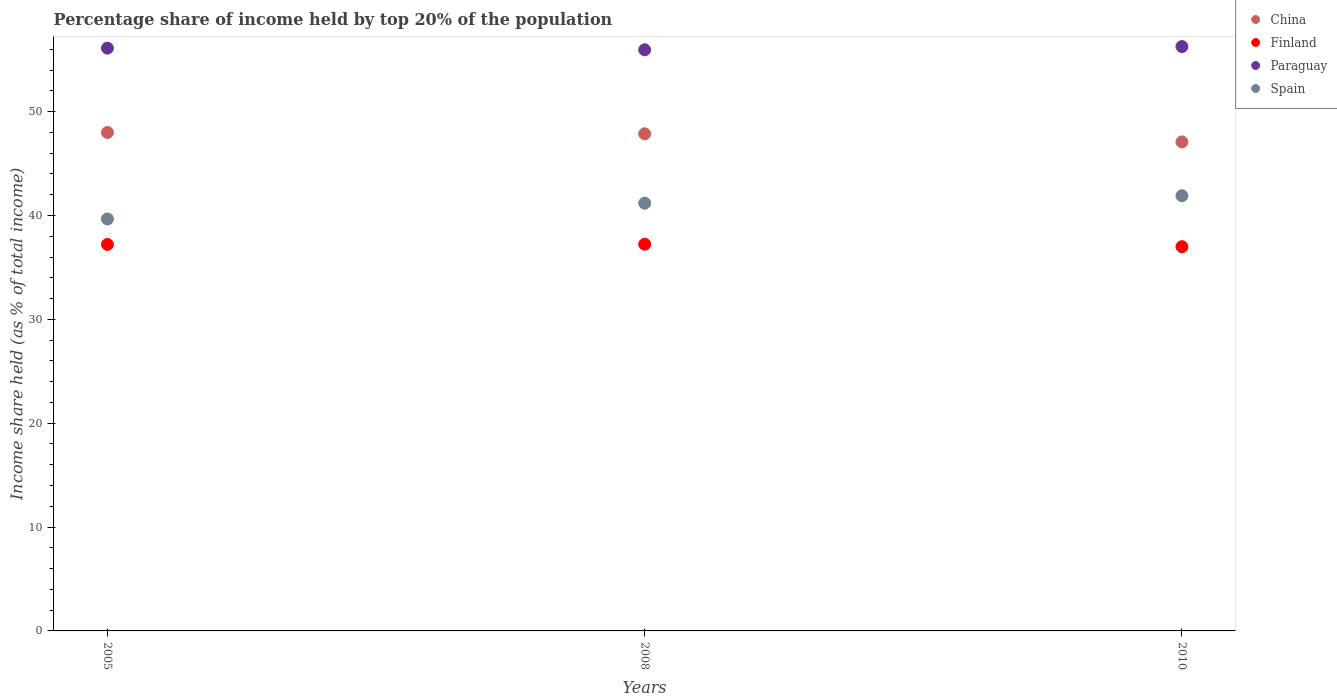How many different coloured dotlines are there?
Give a very brief answer. 4. What is the percentage share of income held by top 20% of the population in Paraguay in 2010?
Your answer should be very brief. 56.27. Across all years, what is the maximum percentage share of income held by top 20% of the population in Spain?
Provide a succinct answer. 41.91. Across all years, what is the minimum percentage share of income held by top 20% of the population in Paraguay?
Your answer should be compact. 55.96. In which year was the percentage share of income held by top 20% of the population in Spain maximum?
Your answer should be compact. 2010. In which year was the percentage share of income held by top 20% of the population in Finland minimum?
Your response must be concise. 2010. What is the total percentage share of income held by top 20% of the population in Paraguay in the graph?
Your answer should be compact. 168.35. What is the difference between the percentage share of income held by top 20% of the population in Finland in 2008 and that in 2010?
Offer a terse response. 0.24. What is the difference between the percentage share of income held by top 20% of the population in China in 2005 and the percentage share of income held by top 20% of the population in Paraguay in 2008?
Offer a very short reply. -7.96. What is the average percentage share of income held by top 20% of the population in China per year?
Ensure brevity in your answer.  47.65. In the year 2005, what is the difference between the percentage share of income held by top 20% of the population in China and percentage share of income held by top 20% of the population in Paraguay?
Your response must be concise. -8.12. What is the ratio of the percentage share of income held by top 20% of the population in Finland in 2008 to that in 2010?
Offer a terse response. 1.01. Is the percentage share of income held by top 20% of the population in Paraguay in 2005 less than that in 2010?
Ensure brevity in your answer.  Yes. What is the difference between the highest and the second highest percentage share of income held by top 20% of the population in Spain?
Make the answer very short. 0.72. What is the difference between the highest and the lowest percentage share of income held by top 20% of the population in Spain?
Provide a succinct answer. 2.24. In how many years, is the percentage share of income held by top 20% of the population in Spain greater than the average percentage share of income held by top 20% of the population in Spain taken over all years?
Provide a succinct answer. 2. Does the percentage share of income held by top 20% of the population in Finland monotonically increase over the years?
Keep it short and to the point. No. Is the percentage share of income held by top 20% of the population in Finland strictly greater than the percentage share of income held by top 20% of the population in Paraguay over the years?
Your response must be concise. No. How many years are there in the graph?
Keep it short and to the point. 3. Does the graph contain any zero values?
Your answer should be very brief. No. Does the graph contain grids?
Provide a succinct answer. No. How many legend labels are there?
Give a very brief answer. 4. What is the title of the graph?
Keep it short and to the point. Percentage share of income held by top 20% of the population. What is the label or title of the X-axis?
Offer a very short reply. Years. What is the label or title of the Y-axis?
Offer a terse response. Income share held (as % of total income). What is the Income share held (as % of total income) of Finland in 2005?
Make the answer very short. 37.22. What is the Income share held (as % of total income) in Paraguay in 2005?
Provide a succinct answer. 56.12. What is the Income share held (as % of total income) in Spain in 2005?
Provide a succinct answer. 39.67. What is the Income share held (as % of total income) in China in 2008?
Your answer should be very brief. 47.87. What is the Income share held (as % of total income) in Finland in 2008?
Offer a very short reply. 37.24. What is the Income share held (as % of total income) of Paraguay in 2008?
Your response must be concise. 55.96. What is the Income share held (as % of total income) of Spain in 2008?
Make the answer very short. 41.19. What is the Income share held (as % of total income) of China in 2010?
Make the answer very short. 47.09. What is the Income share held (as % of total income) in Finland in 2010?
Keep it short and to the point. 37. What is the Income share held (as % of total income) of Paraguay in 2010?
Offer a terse response. 56.27. What is the Income share held (as % of total income) in Spain in 2010?
Your response must be concise. 41.91. Across all years, what is the maximum Income share held (as % of total income) of Finland?
Ensure brevity in your answer.  37.24. Across all years, what is the maximum Income share held (as % of total income) in Paraguay?
Provide a short and direct response. 56.27. Across all years, what is the maximum Income share held (as % of total income) in Spain?
Offer a very short reply. 41.91. Across all years, what is the minimum Income share held (as % of total income) in China?
Keep it short and to the point. 47.09. Across all years, what is the minimum Income share held (as % of total income) of Finland?
Your answer should be very brief. 37. Across all years, what is the minimum Income share held (as % of total income) in Paraguay?
Ensure brevity in your answer.  55.96. Across all years, what is the minimum Income share held (as % of total income) in Spain?
Keep it short and to the point. 39.67. What is the total Income share held (as % of total income) in China in the graph?
Make the answer very short. 142.96. What is the total Income share held (as % of total income) in Finland in the graph?
Your response must be concise. 111.46. What is the total Income share held (as % of total income) of Paraguay in the graph?
Keep it short and to the point. 168.35. What is the total Income share held (as % of total income) of Spain in the graph?
Offer a terse response. 122.77. What is the difference between the Income share held (as % of total income) in China in 2005 and that in 2008?
Your answer should be compact. 0.13. What is the difference between the Income share held (as % of total income) of Finland in 2005 and that in 2008?
Provide a succinct answer. -0.02. What is the difference between the Income share held (as % of total income) of Paraguay in 2005 and that in 2008?
Provide a succinct answer. 0.16. What is the difference between the Income share held (as % of total income) of Spain in 2005 and that in 2008?
Your answer should be very brief. -1.52. What is the difference between the Income share held (as % of total income) of China in 2005 and that in 2010?
Make the answer very short. 0.91. What is the difference between the Income share held (as % of total income) in Finland in 2005 and that in 2010?
Make the answer very short. 0.22. What is the difference between the Income share held (as % of total income) of Spain in 2005 and that in 2010?
Keep it short and to the point. -2.24. What is the difference between the Income share held (as % of total income) in China in 2008 and that in 2010?
Your answer should be very brief. 0.78. What is the difference between the Income share held (as % of total income) in Finland in 2008 and that in 2010?
Give a very brief answer. 0.24. What is the difference between the Income share held (as % of total income) in Paraguay in 2008 and that in 2010?
Your answer should be very brief. -0.31. What is the difference between the Income share held (as % of total income) in Spain in 2008 and that in 2010?
Your answer should be very brief. -0.72. What is the difference between the Income share held (as % of total income) of China in 2005 and the Income share held (as % of total income) of Finland in 2008?
Provide a succinct answer. 10.76. What is the difference between the Income share held (as % of total income) in China in 2005 and the Income share held (as % of total income) in Paraguay in 2008?
Provide a short and direct response. -7.96. What is the difference between the Income share held (as % of total income) in China in 2005 and the Income share held (as % of total income) in Spain in 2008?
Offer a very short reply. 6.81. What is the difference between the Income share held (as % of total income) of Finland in 2005 and the Income share held (as % of total income) of Paraguay in 2008?
Your response must be concise. -18.74. What is the difference between the Income share held (as % of total income) of Finland in 2005 and the Income share held (as % of total income) of Spain in 2008?
Your answer should be very brief. -3.97. What is the difference between the Income share held (as % of total income) in Paraguay in 2005 and the Income share held (as % of total income) in Spain in 2008?
Your answer should be very brief. 14.93. What is the difference between the Income share held (as % of total income) of China in 2005 and the Income share held (as % of total income) of Finland in 2010?
Ensure brevity in your answer.  11. What is the difference between the Income share held (as % of total income) of China in 2005 and the Income share held (as % of total income) of Paraguay in 2010?
Your answer should be compact. -8.27. What is the difference between the Income share held (as % of total income) in China in 2005 and the Income share held (as % of total income) in Spain in 2010?
Keep it short and to the point. 6.09. What is the difference between the Income share held (as % of total income) in Finland in 2005 and the Income share held (as % of total income) in Paraguay in 2010?
Your answer should be very brief. -19.05. What is the difference between the Income share held (as % of total income) in Finland in 2005 and the Income share held (as % of total income) in Spain in 2010?
Provide a short and direct response. -4.69. What is the difference between the Income share held (as % of total income) in Paraguay in 2005 and the Income share held (as % of total income) in Spain in 2010?
Your answer should be compact. 14.21. What is the difference between the Income share held (as % of total income) in China in 2008 and the Income share held (as % of total income) in Finland in 2010?
Keep it short and to the point. 10.87. What is the difference between the Income share held (as % of total income) of China in 2008 and the Income share held (as % of total income) of Spain in 2010?
Provide a succinct answer. 5.96. What is the difference between the Income share held (as % of total income) of Finland in 2008 and the Income share held (as % of total income) of Paraguay in 2010?
Ensure brevity in your answer.  -19.03. What is the difference between the Income share held (as % of total income) of Finland in 2008 and the Income share held (as % of total income) of Spain in 2010?
Your response must be concise. -4.67. What is the difference between the Income share held (as % of total income) of Paraguay in 2008 and the Income share held (as % of total income) of Spain in 2010?
Offer a very short reply. 14.05. What is the average Income share held (as % of total income) of China per year?
Make the answer very short. 47.65. What is the average Income share held (as % of total income) in Finland per year?
Offer a very short reply. 37.15. What is the average Income share held (as % of total income) in Paraguay per year?
Provide a short and direct response. 56.12. What is the average Income share held (as % of total income) of Spain per year?
Your answer should be compact. 40.92. In the year 2005, what is the difference between the Income share held (as % of total income) in China and Income share held (as % of total income) in Finland?
Offer a very short reply. 10.78. In the year 2005, what is the difference between the Income share held (as % of total income) of China and Income share held (as % of total income) of Paraguay?
Your answer should be very brief. -8.12. In the year 2005, what is the difference between the Income share held (as % of total income) of China and Income share held (as % of total income) of Spain?
Your answer should be compact. 8.33. In the year 2005, what is the difference between the Income share held (as % of total income) in Finland and Income share held (as % of total income) in Paraguay?
Provide a succinct answer. -18.9. In the year 2005, what is the difference between the Income share held (as % of total income) of Finland and Income share held (as % of total income) of Spain?
Your answer should be compact. -2.45. In the year 2005, what is the difference between the Income share held (as % of total income) of Paraguay and Income share held (as % of total income) of Spain?
Offer a very short reply. 16.45. In the year 2008, what is the difference between the Income share held (as % of total income) of China and Income share held (as % of total income) of Finland?
Offer a very short reply. 10.63. In the year 2008, what is the difference between the Income share held (as % of total income) of China and Income share held (as % of total income) of Paraguay?
Ensure brevity in your answer.  -8.09. In the year 2008, what is the difference between the Income share held (as % of total income) in China and Income share held (as % of total income) in Spain?
Give a very brief answer. 6.68. In the year 2008, what is the difference between the Income share held (as % of total income) in Finland and Income share held (as % of total income) in Paraguay?
Your answer should be compact. -18.72. In the year 2008, what is the difference between the Income share held (as % of total income) of Finland and Income share held (as % of total income) of Spain?
Provide a short and direct response. -3.95. In the year 2008, what is the difference between the Income share held (as % of total income) of Paraguay and Income share held (as % of total income) of Spain?
Offer a very short reply. 14.77. In the year 2010, what is the difference between the Income share held (as % of total income) of China and Income share held (as % of total income) of Finland?
Your response must be concise. 10.09. In the year 2010, what is the difference between the Income share held (as % of total income) in China and Income share held (as % of total income) in Paraguay?
Your answer should be very brief. -9.18. In the year 2010, what is the difference between the Income share held (as % of total income) in China and Income share held (as % of total income) in Spain?
Provide a short and direct response. 5.18. In the year 2010, what is the difference between the Income share held (as % of total income) in Finland and Income share held (as % of total income) in Paraguay?
Your response must be concise. -19.27. In the year 2010, what is the difference between the Income share held (as % of total income) of Finland and Income share held (as % of total income) of Spain?
Provide a short and direct response. -4.91. In the year 2010, what is the difference between the Income share held (as % of total income) of Paraguay and Income share held (as % of total income) of Spain?
Provide a succinct answer. 14.36. What is the ratio of the Income share held (as % of total income) in Spain in 2005 to that in 2008?
Offer a very short reply. 0.96. What is the ratio of the Income share held (as % of total income) of China in 2005 to that in 2010?
Provide a short and direct response. 1.02. What is the ratio of the Income share held (as % of total income) of Finland in 2005 to that in 2010?
Ensure brevity in your answer.  1.01. What is the ratio of the Income share held (as % of total income) of Spain in 2005 to that in 2010?
Offer a very short reply. 0.95. What is the ratio of the Income share held (as % of total income) of China in 2008 to that in 2010?
Keep it short and to the point. 1.02. What is the ratio of the Income share held (as % of total income) of Paraguay in 2008 to that in 2010?
Provide a short and direct response. 0.99. What is the ratio of the Income share held (as % of total income) of Spain in 2008 to that in 2010?
Provide a short and direct response. 0.98. What is the difference between the highest and the second highest Income share held (as % of total income) of China?
Give a very brief answer. 0.13. What is the difference between the highest and the second highest Income share held (as % of total income) in Finland?
Give a very brief answer. 0.02. What is the difference between the highest and the second highest Income share held (as % of total income) of Paraguay?
Your answer should be compact. 0.15. What is the difference between the highest and the second highest Income share held (as % of total income) in Spain?
Give a very brief answer. 0.72. What is the difference between the highest and the lowest Income share held (as % of total income) in China?
Offer a very short reply. 0.91. What is the difference between the highest and the lowest Income share held (as % of total income) in Finland?
Your answer should be very brief. 0.24. What is the difference between the highest and the lowest Income share held (as % of total income) in Paraguay?
Provide a succinct answer. 0.31. What is the difference between the highest and the lowest Income share held (as % of total income) of Spain?
Your answer should be very brief. 2.24. 